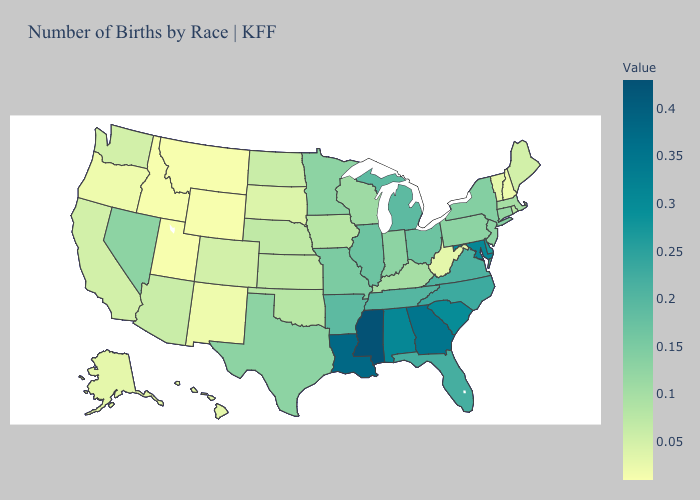Does Mississippi have the highest value in the South?
Give a very brief answer. Yes. Among the states that border New York , does New Jersey have the highest value?
Write a very short answer. Yes. Does the map have missing data?
Answer briefly. No. Does Mississippi have the highest value in the South?
Quick response, please. Yes. Does the map have missing data?
Write a very short answer. No. Among the states that border Missouri , does Arkansas have the highest value?
Be succinct. No. Among the states that border Connecticut , which have the highest value?
Short answer required. New York. Among the states that border Nebraska , does Missouri have the highest value?
Quick response, please. Yes. Is the legend a continuous bar?
Give a very brief answer. Yes. 